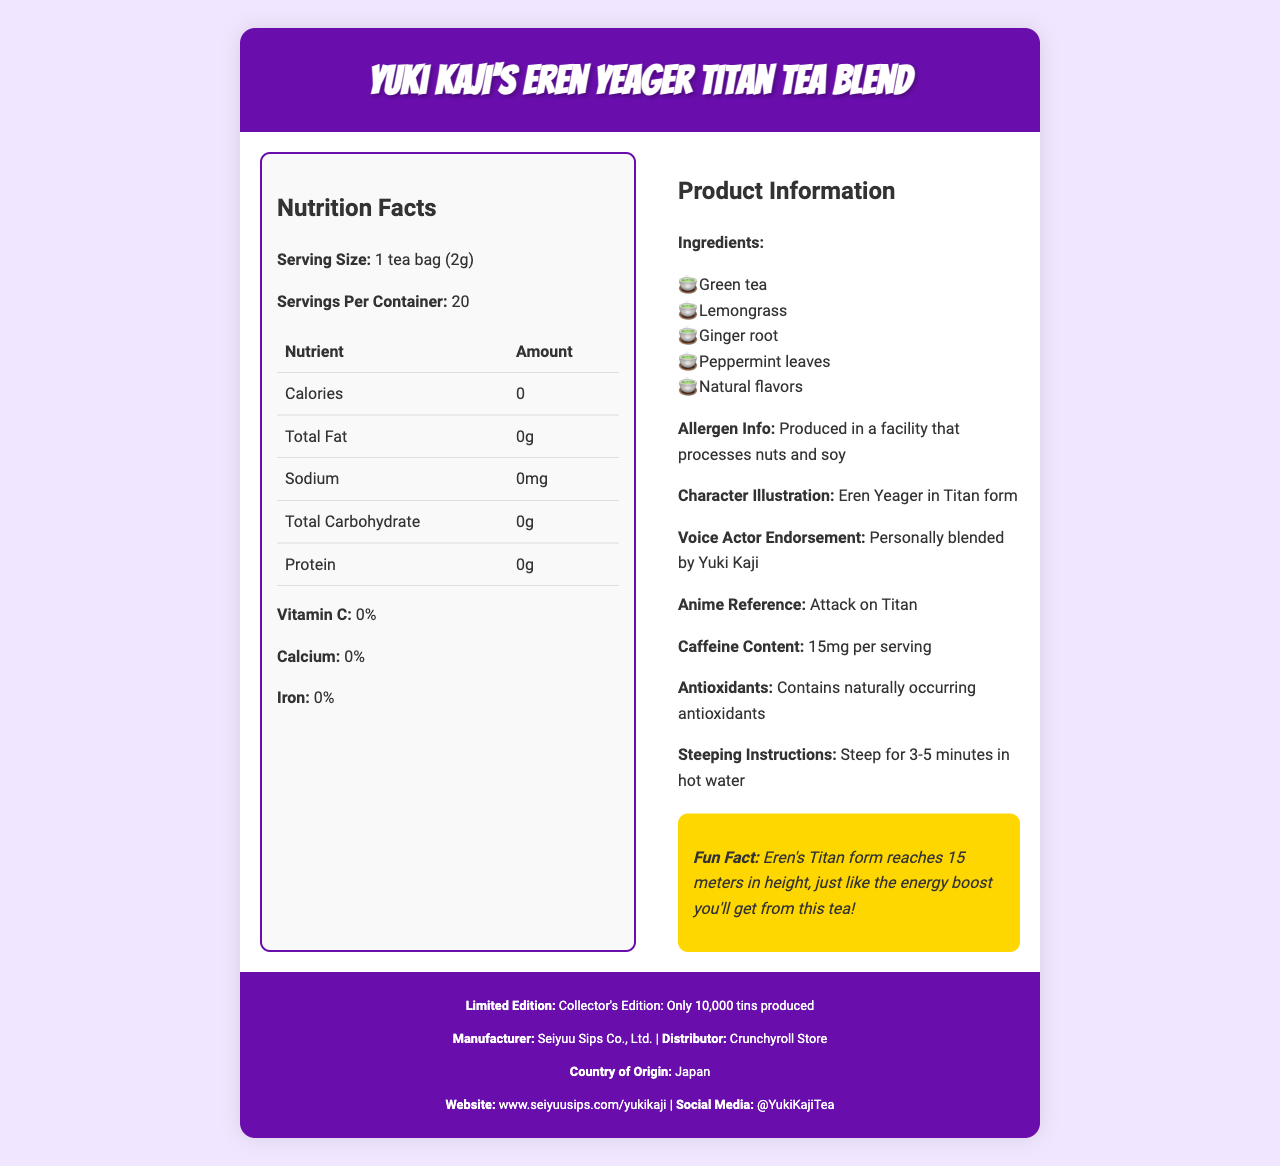what is the product name? The product name is displayed prominently at the top of the document in the header section.
Answer: Yuki Kaji's Eren Yeager Titan Tea Blend how many servings are there per container? The number of servings per container is mentioned in the Nutrition Facts section under 'Servings Per Container.'
Answer: 20 what is the main ingredient in the tea blend? The main ingredient is listed first in the ingredients list in the Product Information section, which typically indicates the primary component.
Answer: Green tea what is the caffeine content per serving? The caffeine content is explicitly mentioned in the Product Information section under 'Caffeine Content.'
Answer: 15mg per serving who endorsed and blended this tea? The endorsement by Yuki Kaji is found in the Product Information section with the statement 'Personally blended by Yuki Kaji.'
Answer: Yuki Kaji which anime character is illustrated on the tea blend? The character illustration is described in the Product Information section under 'Character Illustration.'
Answer: Eren Yeager in Titan form how long should you steep the tea? The steeping instructions are found in the Product Information section with the notice 'Steep for 3-5 minutes in hot water.'
Answer: 3-5 minutes what is the fun fact related to the tea blend? The fun fact is highlighted in the Product Information section under the 'Fun Fact' section.
Answer: Eren's Titan form reaches 15 meters in height, just like the energy boost you'll get from this tea! which nutrient has the most minimal amount in the tea blend? A. Vitamin C B. Sodium C. Protein D. Iron Eren Yeager's Titan Tea Blend contains 0% of Vitamin C, as shown in the Nutrition Facts section under 'Vitamin C.'
Answer: A. Vitamin C who is the manufacturer of the tea blend? A. Crunchyroll Store B. Studio Pierrot C. Seiyuu Sips Co., Ltd. D. Yuki Kaji The manufacturer information is clearly stated in the footer with 'Manufacturer: Seiyuu Sips Co., Ltd.'
Answer: C. Seiyuu Sips Co., Ltd. is this tea blend a collector's edition? The footer explicitly mentions 'Collector's Edition: Only 10,000 tins produced,' indicating that this is a limited edition.
Answer: Yes summarize the main idea of the document. The main idea is to offer comprehensive details about the herbal tea blend, including its nutritional facts, character appeal, and specialties, making it appealing for fans of Yuki Kaji and the Attack on Titan anime.
Answer: The document provides nutritional and product information for Yuki Kaji's Eren Yeager Titan Tea Blend, a limited-edition herbal tea blend endorsed by Yuki Kaji and featuring Eren Yeager from Attack on Titan. It includes details on ingredients, allergen info, nutritional content, caffeine content, antioxidants, steeping instructions, and a fun fact related to the character. Additionally, it mentions the manufacturer, distributor, country of origin, website, and social media. what is the exact height of Eren's Titan form? The document mentions that Eren's Titan form reaches 15 meters, but it doesn't specify additional precise details beyond the height.
Answer: Not enough information 